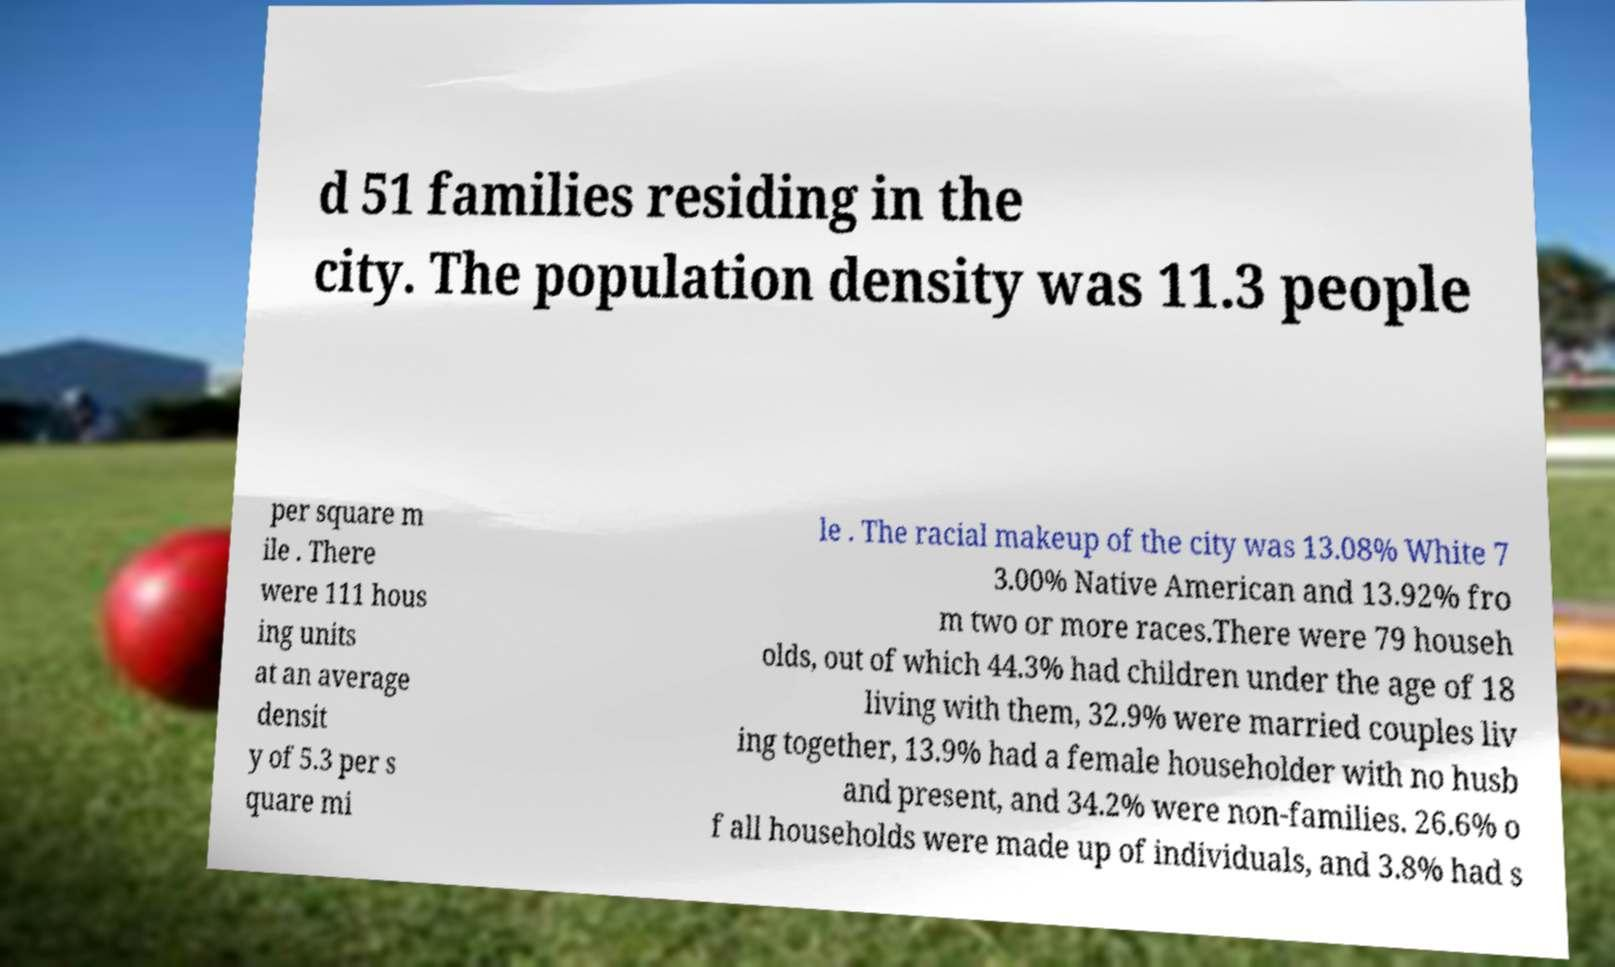There's text embedded in this image that I need extracted. Can you transcribe it verbatim? d 51 families residing in the city. The population density was 11.3 people per square m ile . There were 111 hous ing units at an average densit y of 5.3 per s quare mi le . The racial makeup of the city was 13.08% White 7 3.00% Native American and 13.92% fro m two or more races.There were 79 househ olds, out of which 44.3% had children under the age of 18 living with them, 32.9% were married couples liv ing together, 13.9% had a female householder with no husb and present, and 34.2% were non-families. 26.6% o f all households were made up of individuals, and 3.8% had s 